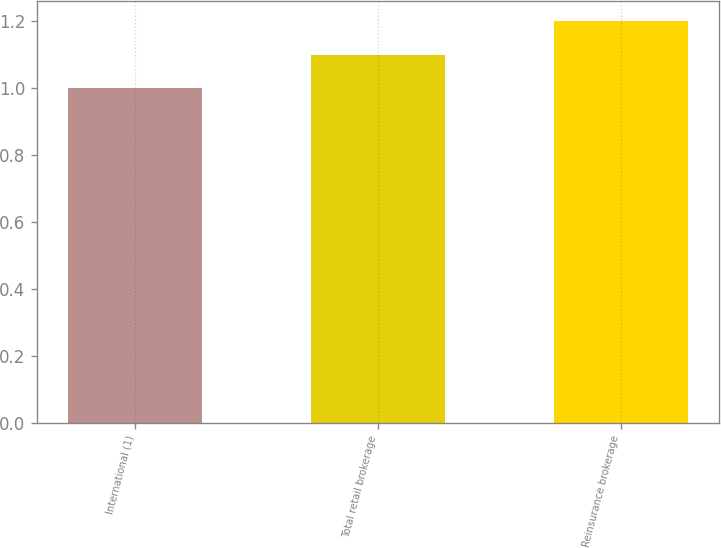Convert chart to OTSL. <chart><loc_0><loc_0><loc_500><loc_500><bar_chart><fcel>International (1)<fcel>Total retail brokerage<fcel>Reinsurance brokerage<nl><fcel>1<fcel>1.1<fcel>1.2<nl></chart> 